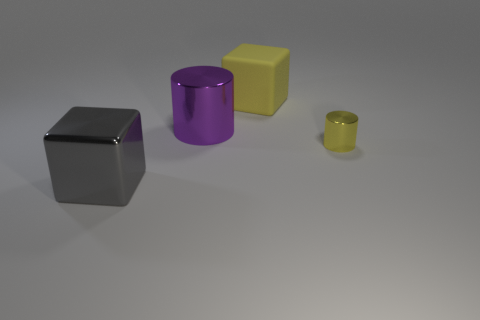Add 4 small yellow shiny things. How many objects exist? 8 Subtract all gray cubes. Subtract all large gray things. How many objects are left? 2 Add 1 metal things. How many metal things are left? 4 Add 2 gray shiny blocks. How many gray shiny blocks exist? 3 Subtract 1 yellow cylinders. How many objects are left? 3 